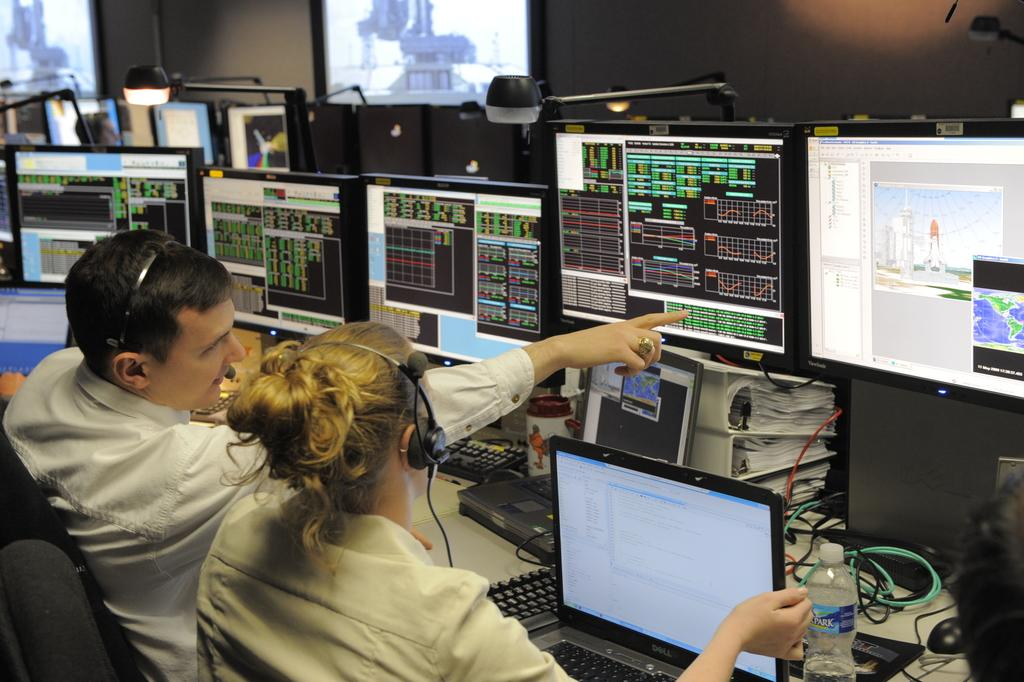What is the main subject in the center of the image? There are monitors in the center of the image. Can you describe the people in the image? There is a man and a woman in the image. Where are the man and the woman located in the image? Both the man and the woman are on the left side of the image. What type of mind can be seen in the image? There is no mind present in the image; it features monitors, a man, and a woman. Can you tell me how many mittens are visible in the image? There are no mittens present in the image. 